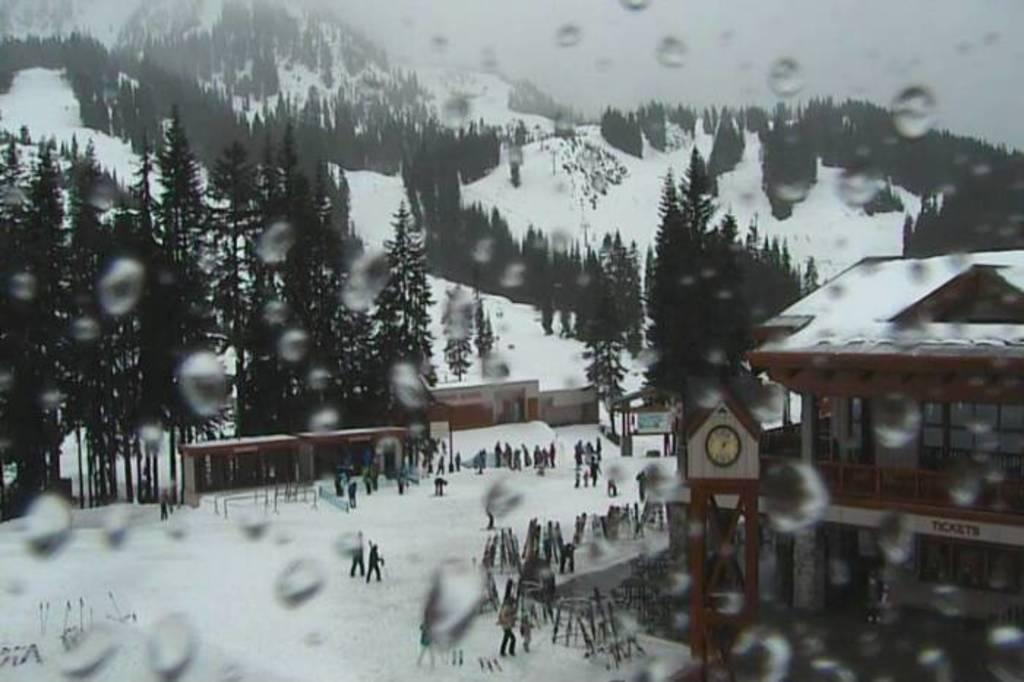What type of natural elements can be seen in the image? There are trees and mountains visible in the image. What type of structures are present in the image? There are houses and a clock tower in the image. Are there any people in the image? Yes, there are persons in the image. What is the weather like in the image? There is snow visible in the image, indicating a cold or wintery environment. What is visible in the background of the image? The sky is visible in the image. What story is being told by the clock tower in the image? The clock tower is not telling a story; it is a structure with a clock face and is likely used for timekeeping purposes. What knowledge can be gained from the snow in the image? The snow in the image indicates the weather or season, but it does not provide any specific knowledge beyond that. 